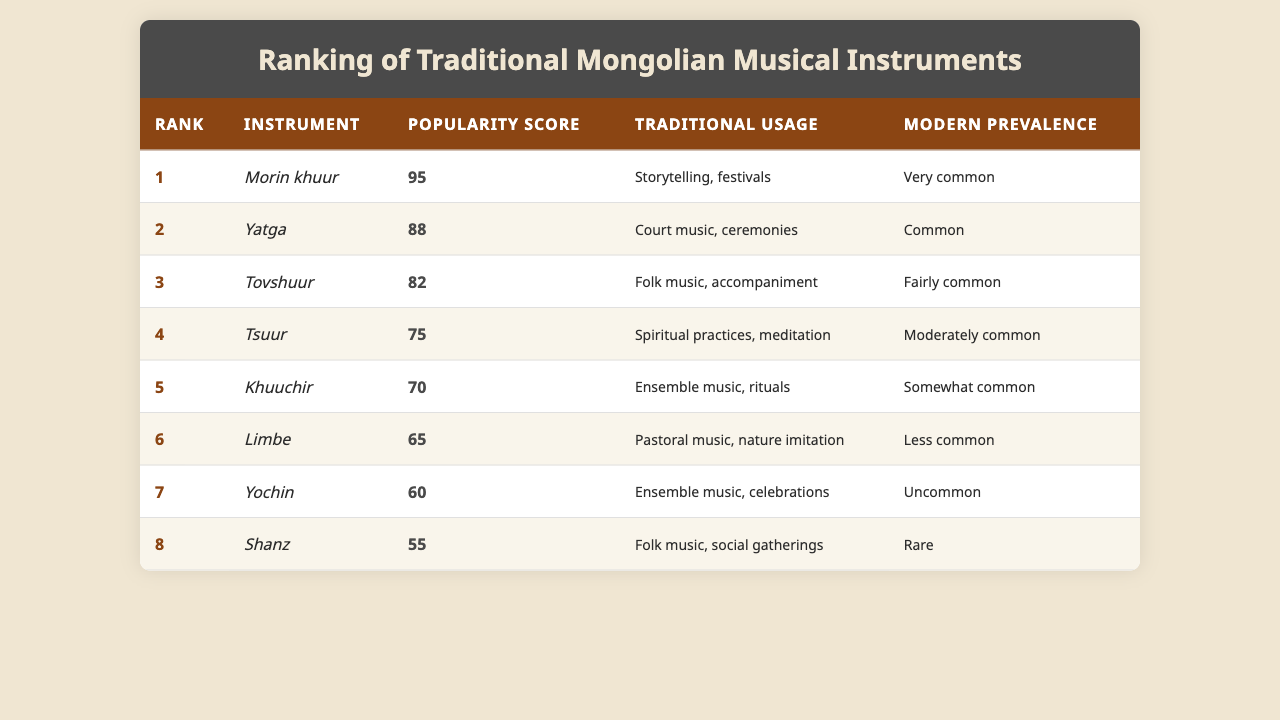What is the most popular traditional Mongolian musical instrument? The table shows that the "Morin khuur" has the highest popularity score of 95, indicating it is the most popular instrument listed.
Answer: Morin khuur Which instrument has a popularity score of 70? According to the table, the instrument listed with a popularity score of 70 is the "Khuuchir."
Answer: Khuuchir What is the traditional usage of the "Tsuur"? By examining the table, it states that the "Tsuur" is traditionally used in spiritual practices and meditation.
Answer: Spiritual practices, meditation How many instruments have a popularity score greater than 80? The instruments with popularity scores greater than 80 are the "Morin khuur" (95), "Yatga" (88), and "Tovshuur" (82), making a total of 3 instruments.
Answer: 3 Is the "Shanz" commonly used in modern times? The table indicates that the "Shanz" has a modern prevalence of "Rare," which means it is not commonly used today.
Answer: No What is the average popularity score of all instruments? The total popularity scores of the instruments are 95 + 88 + 82 + 75 + 70 + 65 + 60 + 55 = 600. Dividing by the number of instruments (8) gives an average score of 600 / 8 = 75.
Answer: 75 Which instrument has the lowest popularity score? From the table, the "Shanz" has the lowest popularity score of 55.
Answer: Shanz What traditional usages are associated with the "Yatga"? The table lists the "Yatga" as being used in court music and ceremonies, identifying its traditional usages.
Answer: Court music, ceremonies How many instruments are fairly common in modern prevalence? The instruments that are labeled as "Fairly common" in modern prevalence are the "Tovshuur," which is 1 instrument.
Answer: 1 Is there any instrument used for pastoral music? Yes, the "Limbe" is specifically mentioned as being used for pastoral music in the table.
Answer: Yes 